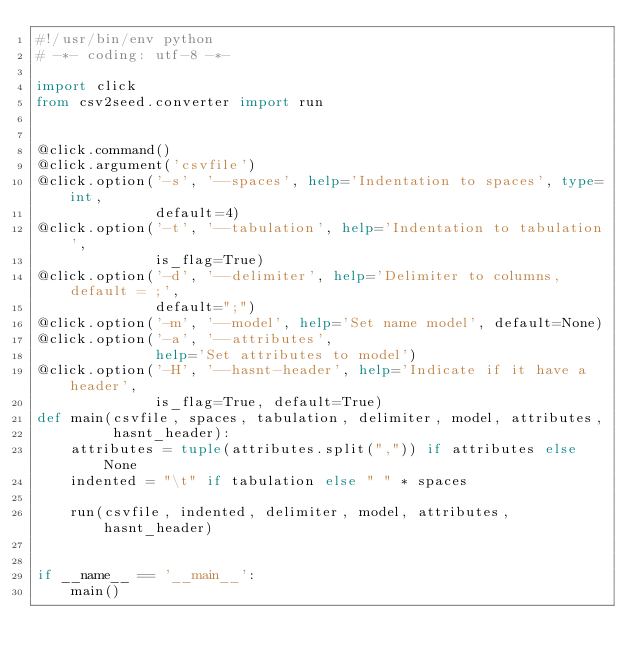Convert code to text. <code><loc_0><loc_0><loc_500><loc_500><_Python_>#!/usr/bin/env python
# -*- coding: utf-8 -*-

import click
from csv2seed.converter import run


@click.command()
@click.argument('csvfile')
@click.option('-s', '--spaces', help='Indentation to spaces', type=int,
              default=4)
@click.option('-t', '--tabulation', help='Indentation to tabulation',
              is_flag=True)
@click.option('-d', '--delimiter', help='Delimiter to columns, default = ;',
              default=";")
@click.option('-m', '--model', help='Set name model', default=None)
@click.option('-a', '--attributes',
              help='Set attributes to model')
@click.option('-H', '--hasnt-header', help='Indicate if it have a header',
              is_flag=True, default=True)
def main(csvfile, spaces, tabulation, delimiter, model, attributes,
         hasnt_header):
    attributes = tuple(attributes.split(",")) if attributes else None
    indented = "\t" if tabulation else " " * spaces

    run(csvfile, indented, delimiter, model, attributes, hasnt_header)


if __name__ == '__main__':
    main()
</code> 